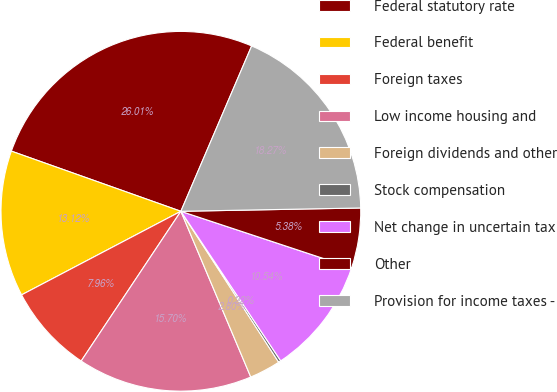<chart> <loc_0><loc_0><loc_500><loc_500><pie_chart><fcel>Federal statutory rate<fcel>Federal benefit<fcel>Foreign taxes<fcel>Low income housing and<fcel>Foreign dividends and other<fcel>Stock compensation<fcel>Net change in uncertain tax<fcel>Other<fcel>Provision for income taxes -<nl><fcel>26.01%<fcel>13.12%<fcel>7.96%<fcel>15.7%<fcel>2.8%<fcel>0.22%<fcel>10.54%<fcel>5.38%<fcel>18.27%<nl></chart> 